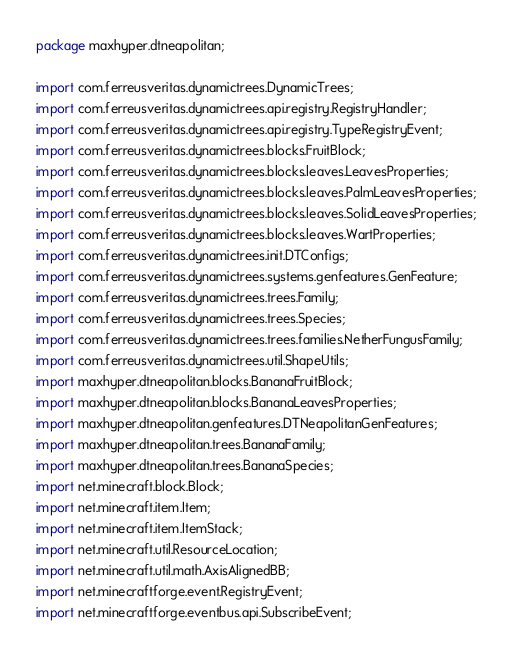<code> <loc_0><loc_0><loc_500><loc_500><_Java_>package maxhyper.dtneapolitan;

import com.ferreusveritas.dynamictrees.DynamicTrees;
import com.ferreusveritas.dynamictrees.api.registry.RegistryHandler;
import com.ferreusveritas.dynamictrees.api.registry.TypeRegistryEvent;
import com.ferreusveritas.dynamictrees.blocks.FruitBlock;
import com.ferreusveritas.dynamictrees.blocks.leaves.LeavesProperties;
import com.ferreusveritas.dynamictrees.blocks.leaves.PalmLeavesProperties;
import com.ferreusveritas.dynamictrees.blocks.leaves.SolidLeavesProperties;
import com.ferreusveritas.dynamictrees.blocks.leaves.WartProperties;
import com.ferreusveritas.dynamictrees.init.DTConfigs;
import com.ferreusveritas.dynamictrees.systems.genfeatures.GenFeature;
import com.ferreusveritas.dynamictrees.trees.Family;
import com.ferreusveritas.dynamictrees.trees.Species;
import com.ferreusveritas.dynamictrees.trees.families.NetherFungusFamily;
import com.ferreusveritas.dynamictrees.util.ShapeUtils;
import maxhyper.dtneapolitan.blocks.BananaFruitBlock;
import maxhyper.dtneapolitan.blocks.BananaLeavesProperties;
import maxhyper.dtneapolitan.genfeatures.DTNeapolitanGenFeatures;
import maxhyper.dtneapolitan.trees.BananaFamily;
import maxhyper.dtneapolitan.trees.BananaSpecies;
import net.minecraft.block.Block;
import net.minecraft.item.Item;
import net.minecraft.item.ItemStack;
import net.minecraft.util.ResourceLocation;
import net.minecraft.util.math.AxisAlignedBB;
import net.minecraftforge.event.RegistryEvent;
import net.minecraftforge.eventbus.api.SubscribeEvent;</code> 